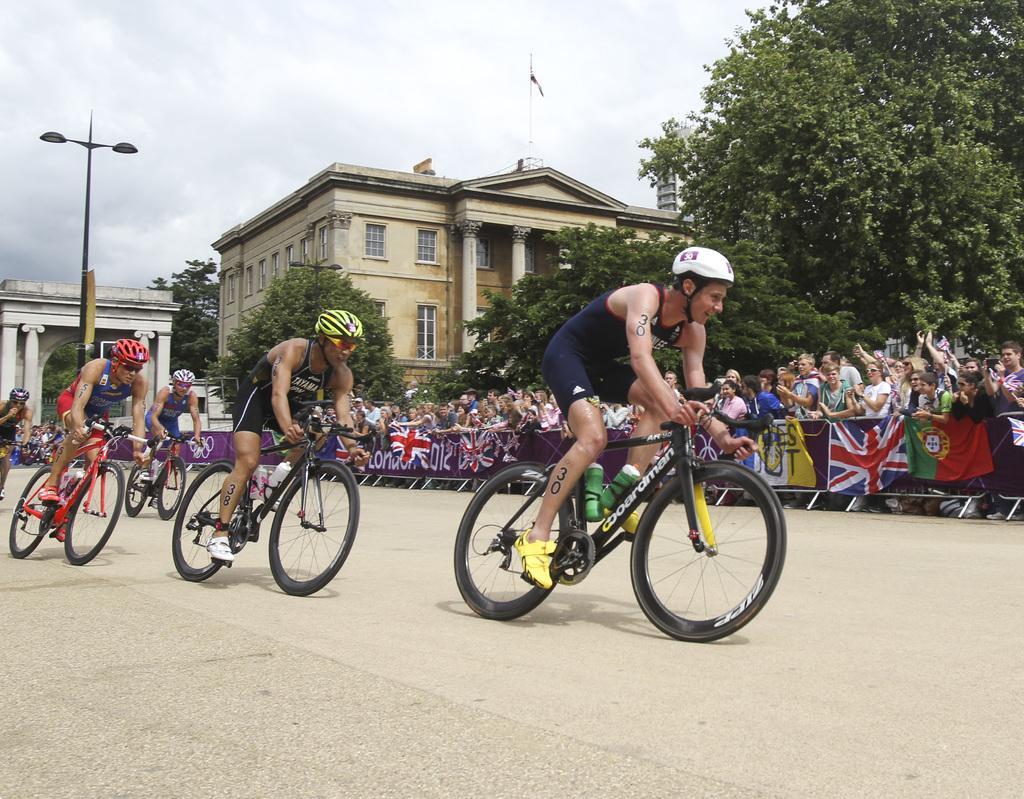How would you summarize this image in a sentence or two? In this picture we can see some persons on the bicycle. This is road. And here we can see persons are standing on the road. These are the trees and there is a building. This is pole and there is a sky. 